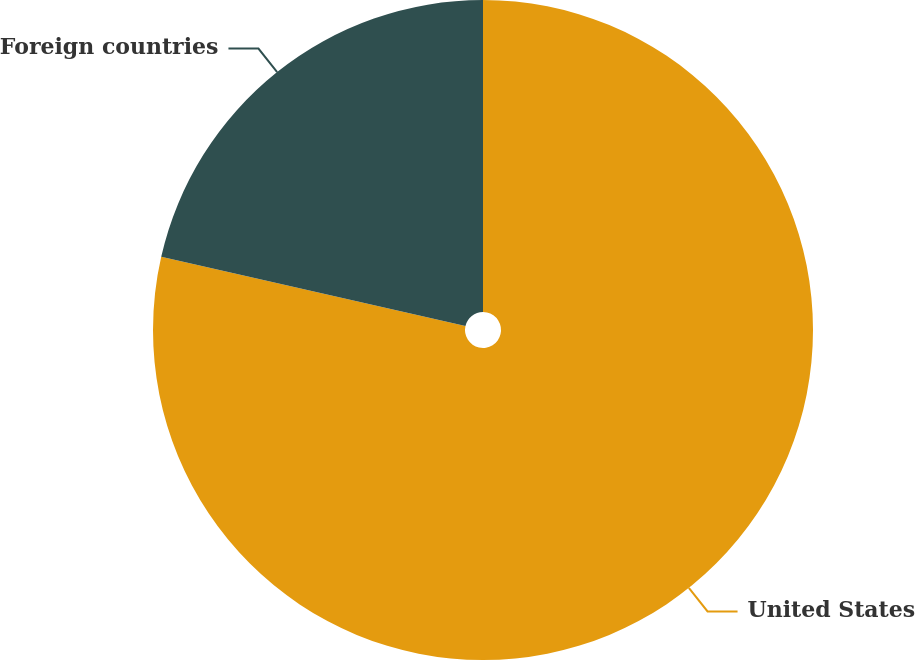<chart> <loc_0><loc_0><loc_500><loc_500><pie_chart><fcel>United States<fcel>Foreign countries<nl><fcel>78.56%<fcel>21.44%<nl></chart> 